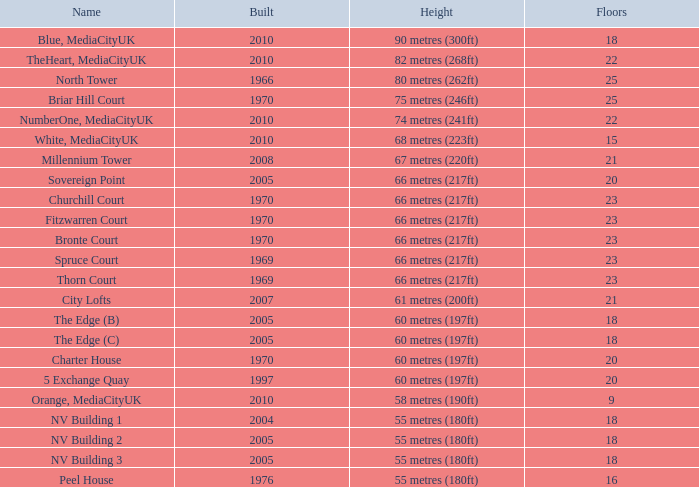What is the total number of Built, when Floors is less than 22, when Rank is less than 8, and when Name is White, Mediacityuk? 1.0. 